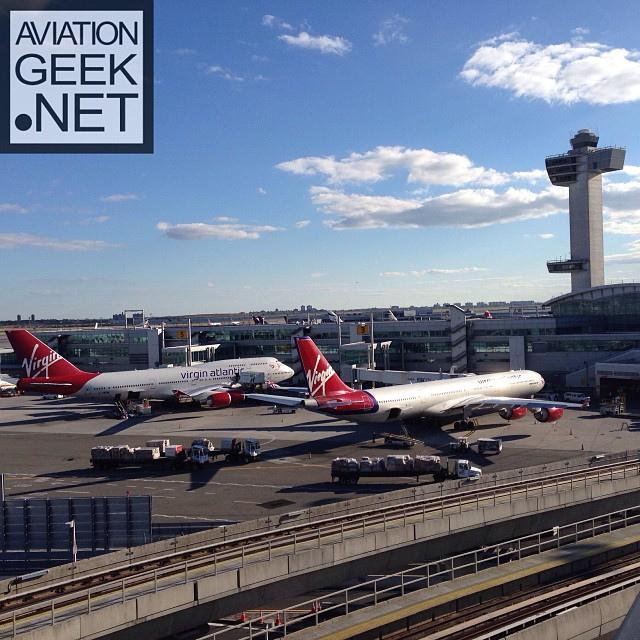What state has a name closest to the name that is found on the vehicle?

Choices:
A) virginia
B) new jersey
C) fordham
D) delaware virginia 